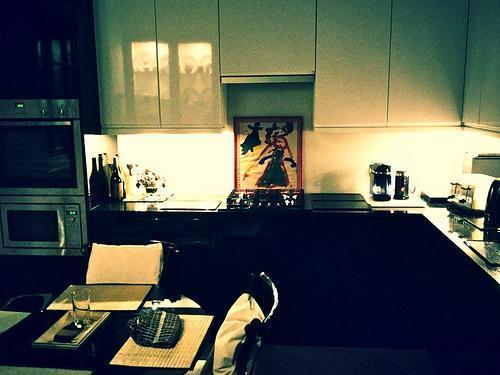How many appliances have visible digital displays?
Give a very brief answer. 2. 